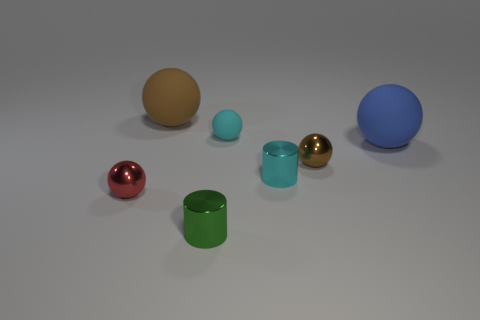Subtract all cyan spheres. How many spheres are left? 4 Subtract all brown shiny balls. How many balls are left? 4 Subtract all purple balls. Subtract all yellow blocks. How many balls are left? 5 Add 2 large matte objects. How many objects exist? 9 Subtract all balls. How many objects are left? 2 Subtract all small cyan cylinders. Subtract all big rubber objects. How many objects are left? 4 Add 2 red balls. How many red balls are left? 3 Add 1 small cyan balls. How many small cyan balls exist? 2 Subtract 0 yellow spheres. How many objects are left? 7 